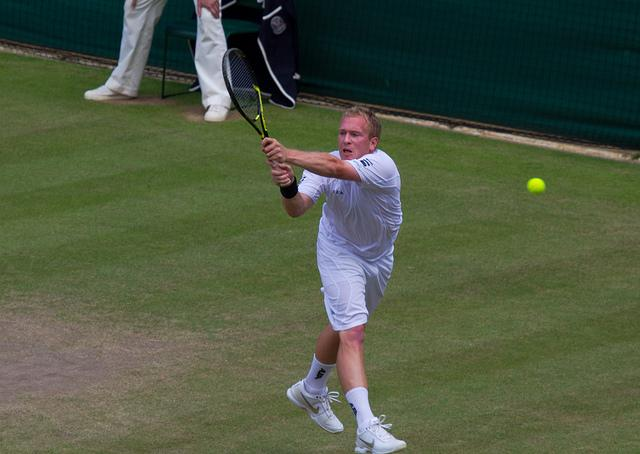What is the player ready to do? Please explain your reasoning. swing. The person is holding a racket and a ball appears to be approaching which means they will likely have to perform answer a in accordance with the rules and purpose of the game. 